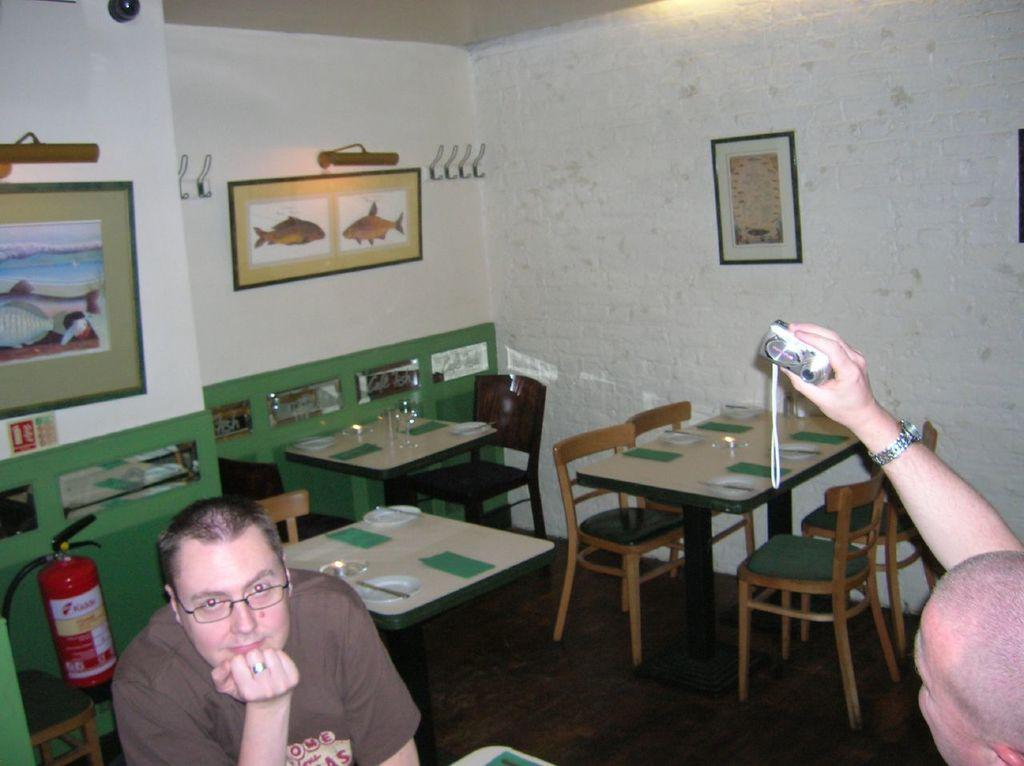How many persons are sitting in the image? There are two persons sitting on chairs in the image. What is the person on the right doing? The person on the right is holding a camera. What can be seen in the background of the image? There is a wall, a photo frame, a hanger, tables, and chairs in the background of the image. What type of thought is being expressed by the person on the left in the image? There is no indication of any thoughts being expressed by the person on the left in the image. Can you tell me the account number of the person on the right in the image? There is no account number visible in the image. 